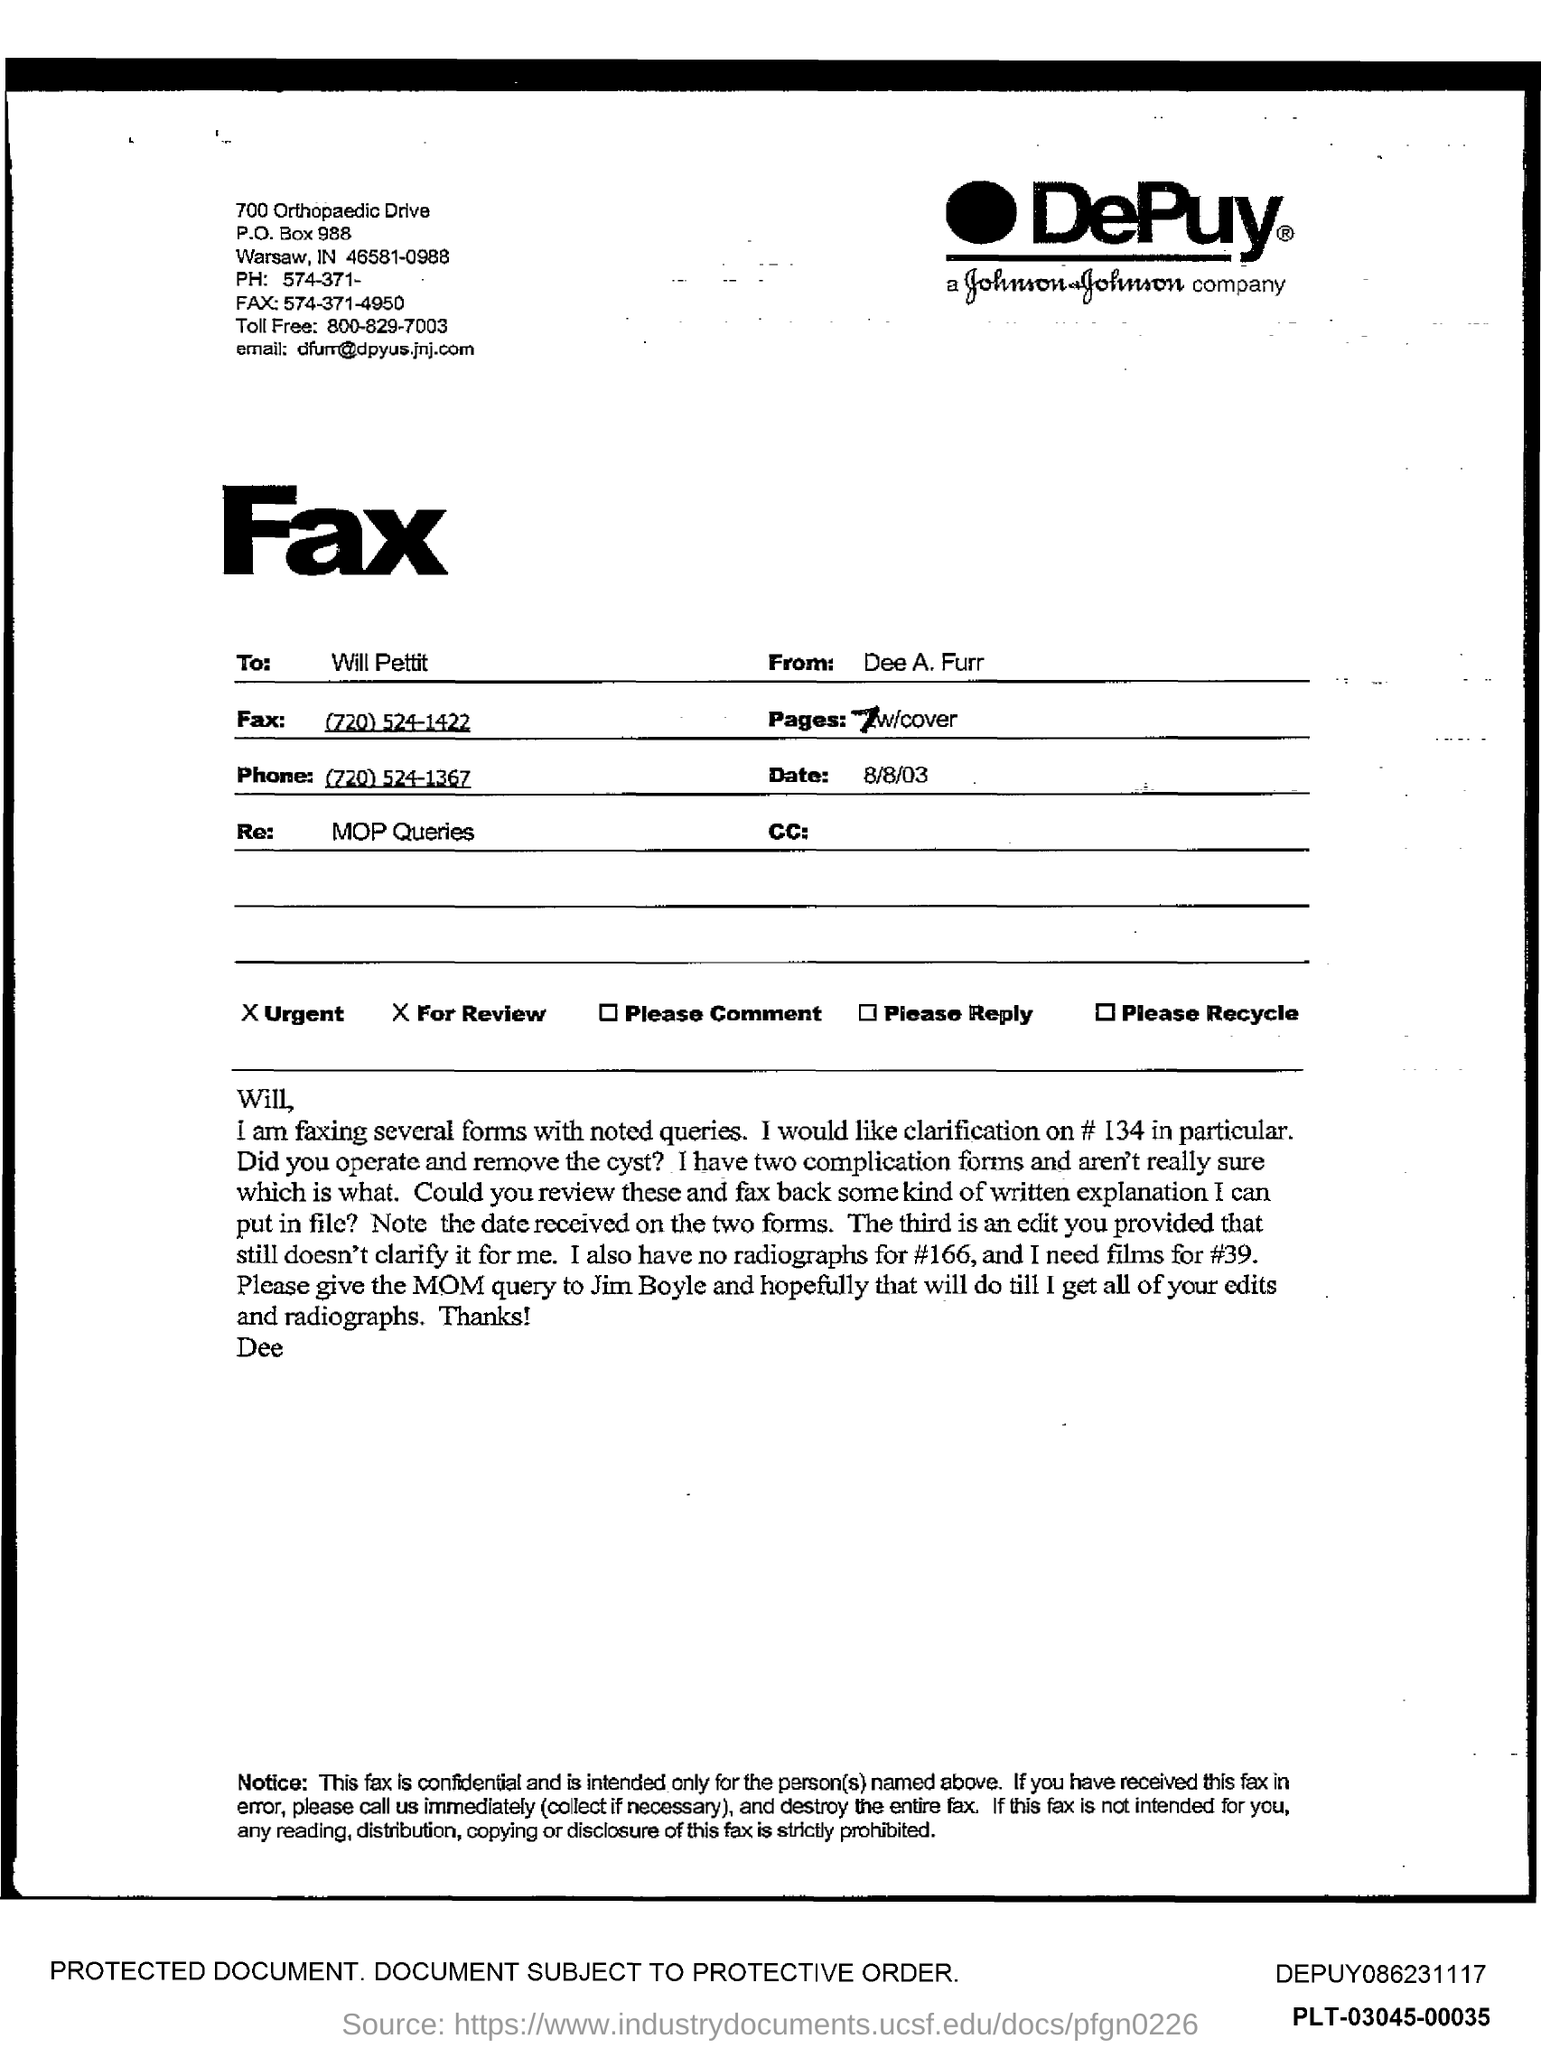Identify some key points in this picture. The phone number is (720) 524-1367. The fax number is (720) 524-1422. On August 8th, 2003, the date is August 8th, 2003. The fax is from Dee A. Furr. 